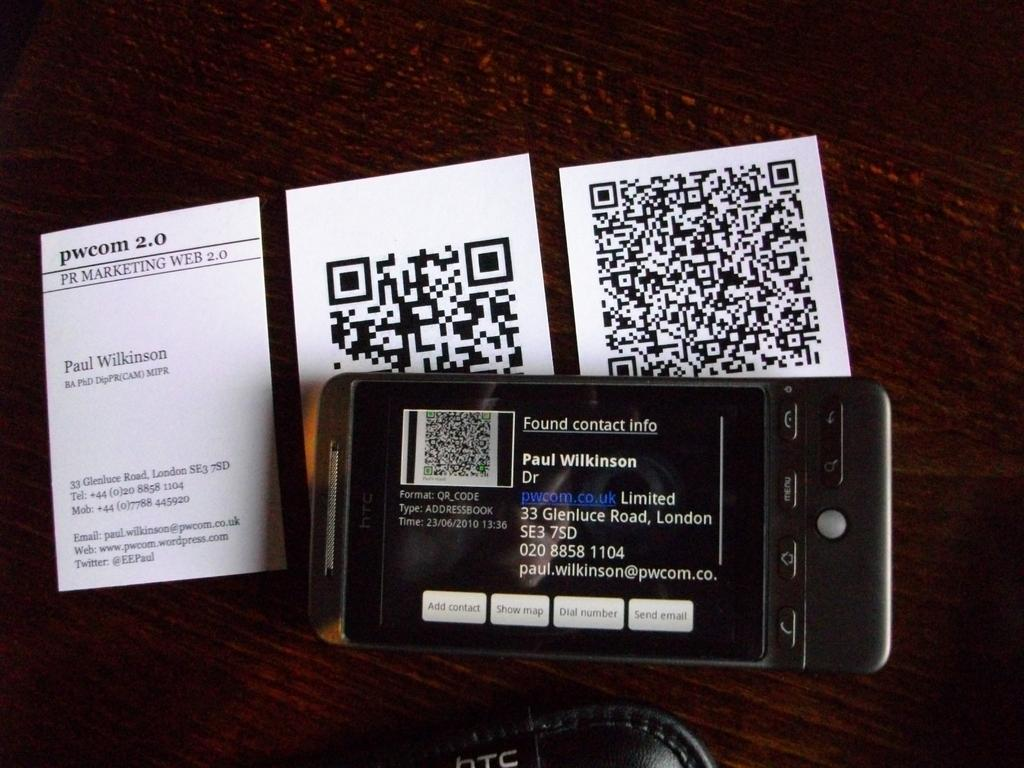<image>
Summarize the visual content of the image. A cell phone with three behind it with barcodes and pwcom 2.0 PR Marketing Web on one. 